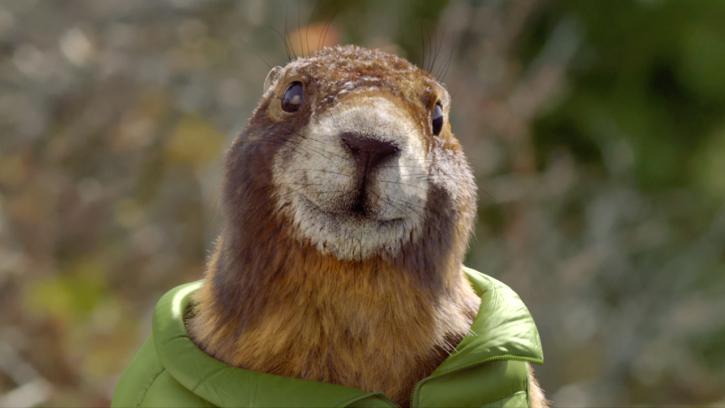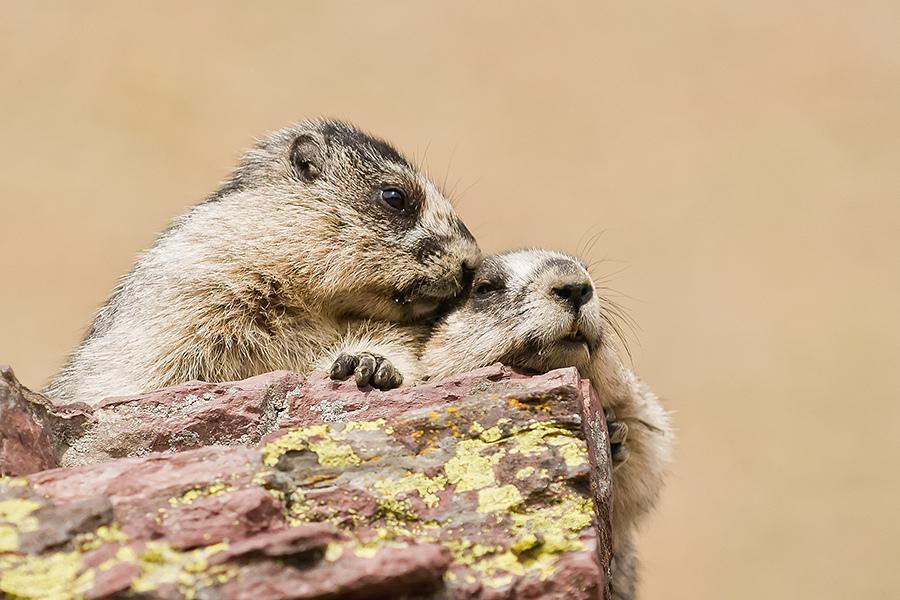The first image is the image on the left, the second image is the image on the right. Evaluate the accuracy of this statement regarding the images: "Each image contains exactly one pair of marmots, and at least one pair is face-to-face.". Is it true? Answer yes or no. No. 